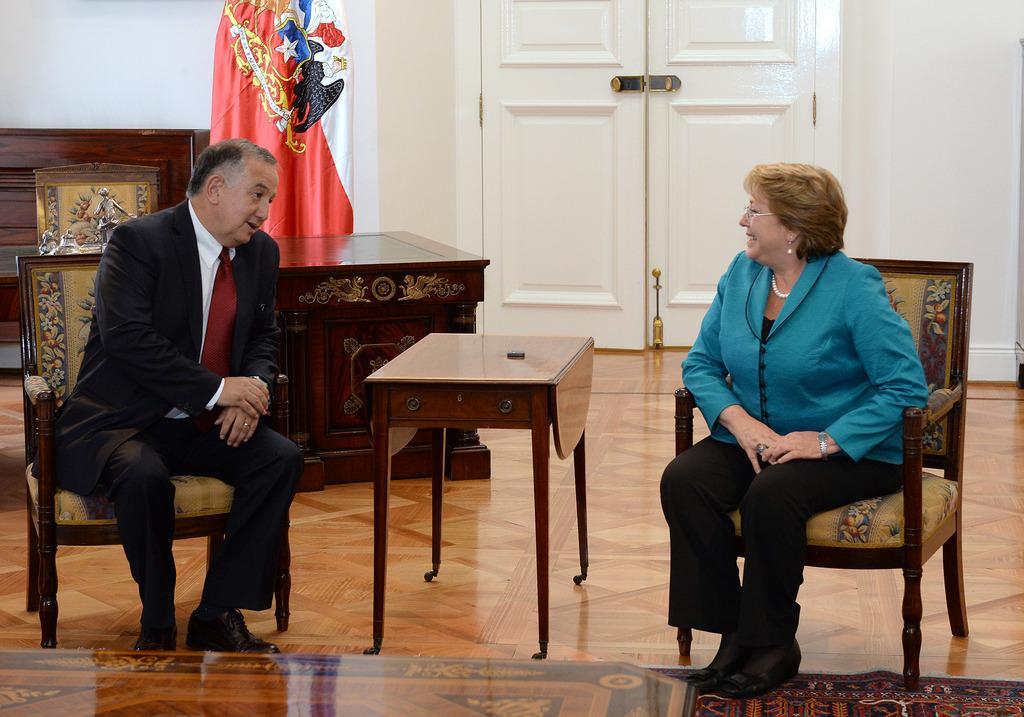Please provide a concise description of this image. Here we can see men and women both sitting on chairs talking to each other with table in front of them and behind them we can see a flag and a door present 